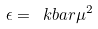<formula> <loc_0><loc_0><loc_500><loc_500>\epsilon = \ k b a r \mu ^ { 2 }</formula> 